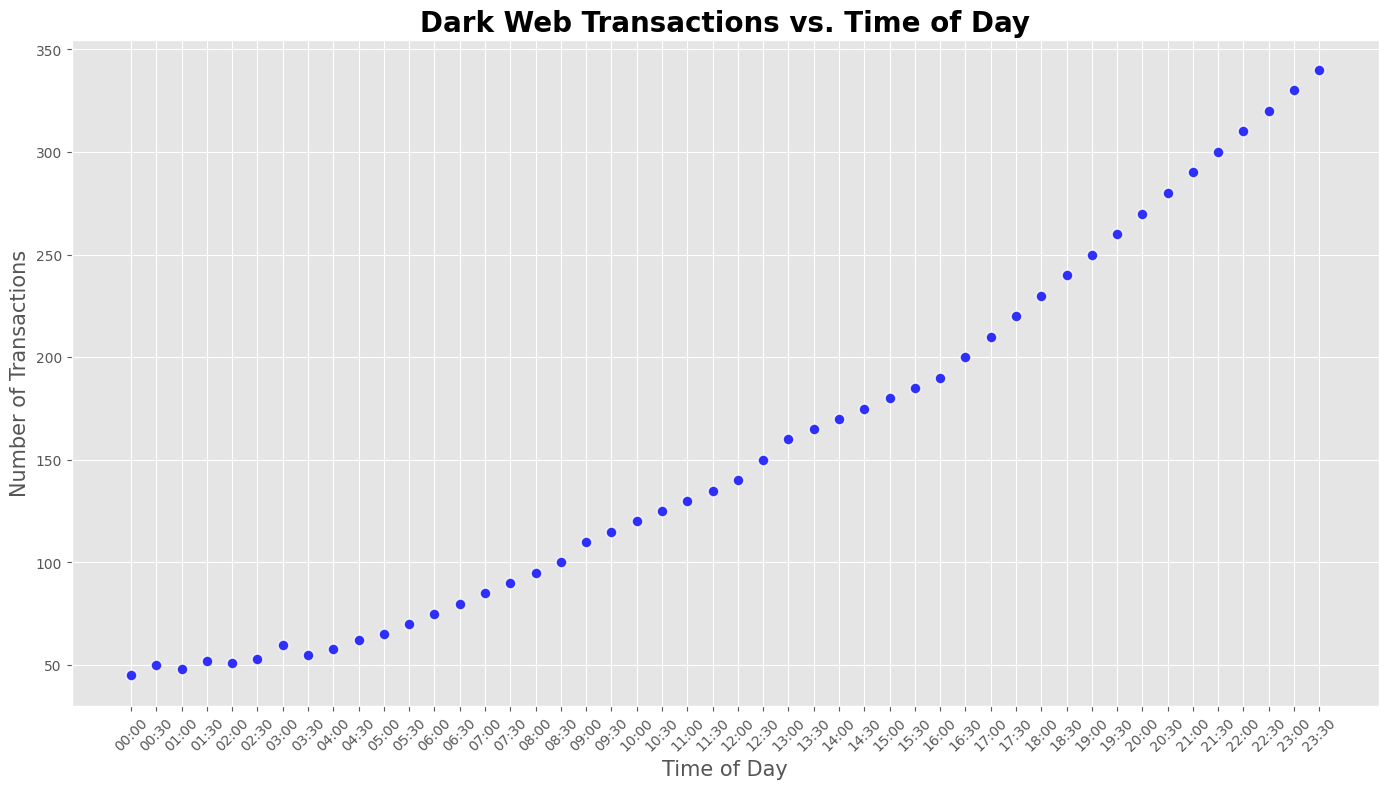What is the peak period for Dark Web transactions in a day? By examining the scatter plot, we see that the number of transactions is highest at 23:30, showing the peak activity period.
Answer: 23:30 How does the number of transactions at 10:00 compare to the number of transactions at 20:00? At 10:00, there are 120 transactions. At 20:00, there are 270 transactions. Therefore, the number of transactions at 20:00 is higher than at 10:00.
Answer: Higher What is the average number of transactions between 00:00 and 06:00? To find the average, sum the transactions from 00:00 to 06:00 and divide by the number of data points: (45+50+48+52+51+53+60+55+58+62+65+70+75)/13 ≈ 58.3.
Answer: 58.3 Is there an increasing trend in transactions throughout the day, and if so, what indicates this in the plot? The scatter plot displays an increasing trend in transactions as time progresses from 00:00 to 23:30, indicated by the rising number of transactions throughout the course of the day.
Answer: Yes, increasing trend Which time period shows the greatest increase in transactions when compared to the previous time period? By examining the plot, the largest increase in transactions occurs between 08:00 and 08:30, jumping from 95 to 100 transactions, an increase of 5 transactions.
Answer: 08:00 to 08:30 What can be inferred about the transactions at midday (12:00) compared to the start of the day (00:00)? At 12:00, the number of transactions is 140, which is significantly higher than the 45 transactions at 00:00, indicating higher activity at midday compared to the start of the day.
Answer: Higher at 12:00 How does the number of transactions vary between the early morning (00:00 to 06:00) and the late evening (18:00 to 23:30)? In the early morning, transactions range from 45 to 75. In the late evening, they rise dramatically from 230 to 340, indicating far more activity in the late evening.
Answer: More in late evening What is the difference in transactions between 09:00 and 16:00? At 09:00, there are 110 transactions. At 16:00, there are 190 transactions. The difference is 190 - 110 = 80 transactions.
Answer: 80 What is the median number of transactions in the data? The median is the middle value when the transactions are ordered. With 48 data points, the median is the average of the 24th and 25th values: (135 + 140)/2 = 137.5.
Answer: 137.5 